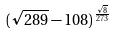<formula> <loc_0><loc_0><loc_500><loc_500>( \sqrt { 2 8 9 } - 1 0 8 ) ^ { \frac { \sqrt { 8 } } { 2 7 3 } }</formula> 